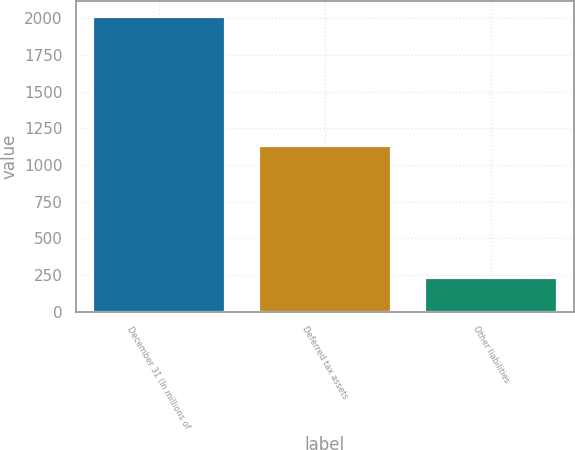Convert chart to OTSL. <chart><loc_0><loc_0><loc_500><loc_500><bar_chart><fcel>December 31 (In millions of<fcel>Deferred tax assets<fcel>Other liabilities<nl><fcel>2015<fcel>1138<fcel>237<nl></chart> 